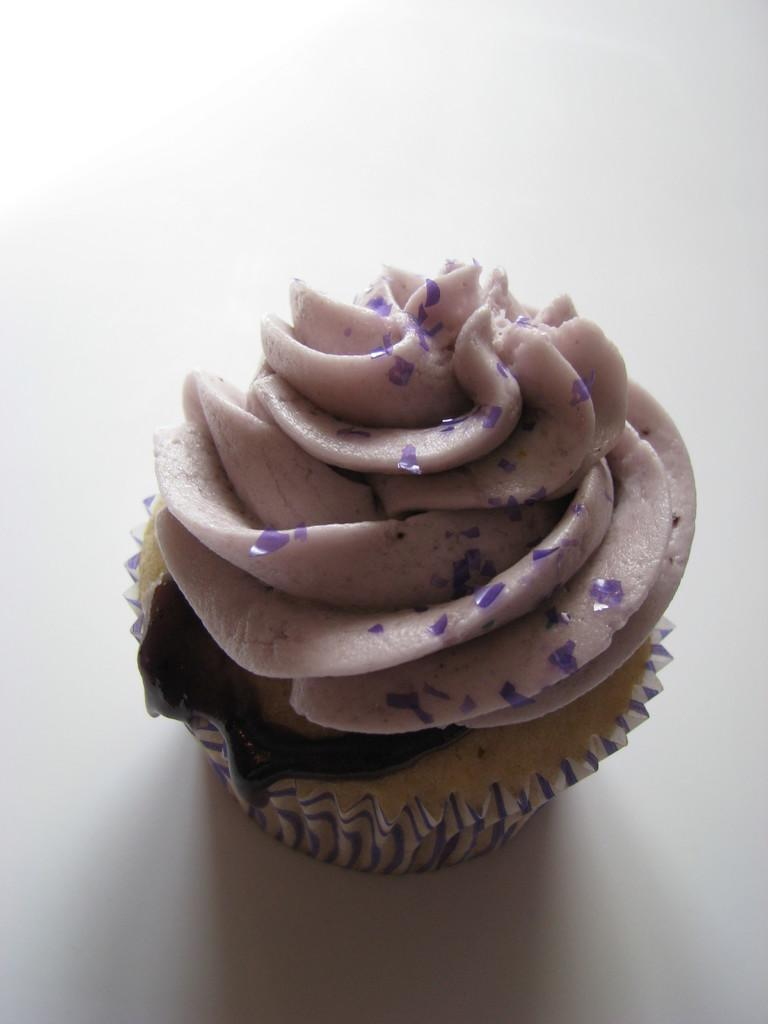What type of dessert is visible in the image? There is a cupcake in the image. What type of curve can be seen in the town's sidewalk in the image? There is no town or sidewalk present in the image; it only features a cupcake. 